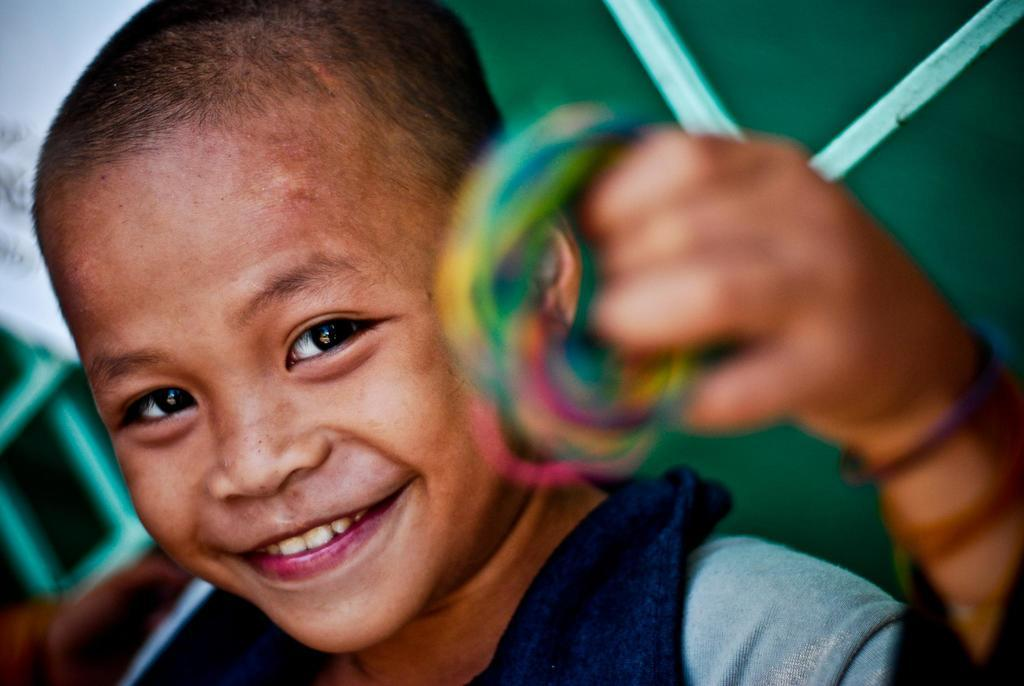What is the main subject of the picture? The main subject of the picture is a boy. What is the boy holding in his hand? The boy is holding something in his hand, but the specific object is not mentioned in the facts. What can be seen in the background of the image? There is a metal grill in the background of the image. Is the boy's grandmother wearing a crown in the image? There is no mention of a grandmother or a crown in the image, so we cannot answer this question. 